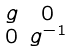<formula> <loc_0><loc_0><loc_500><loc_500>\begin{smallmatrix} g & 0 \\ 0 & g ^ { - 1 } \end{smallmatrix}</formula> 